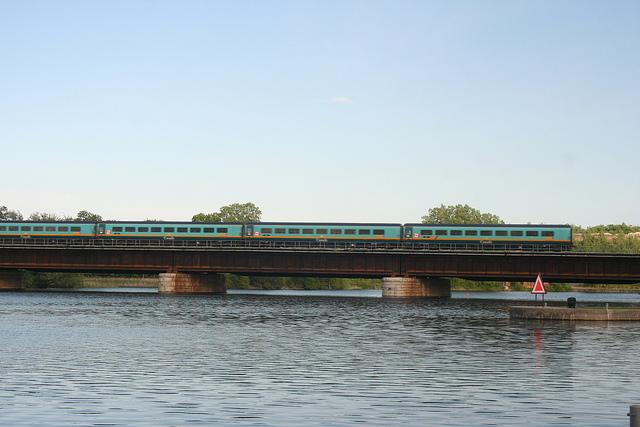How many cars long is the train?
Concise answer only. 4. What kind of area is this?
Give a very brief answer. Lake. What shape is the red marker in the water?
Keep it brief. Triangle. What is under the bridge?
Quick response, please. Water. 